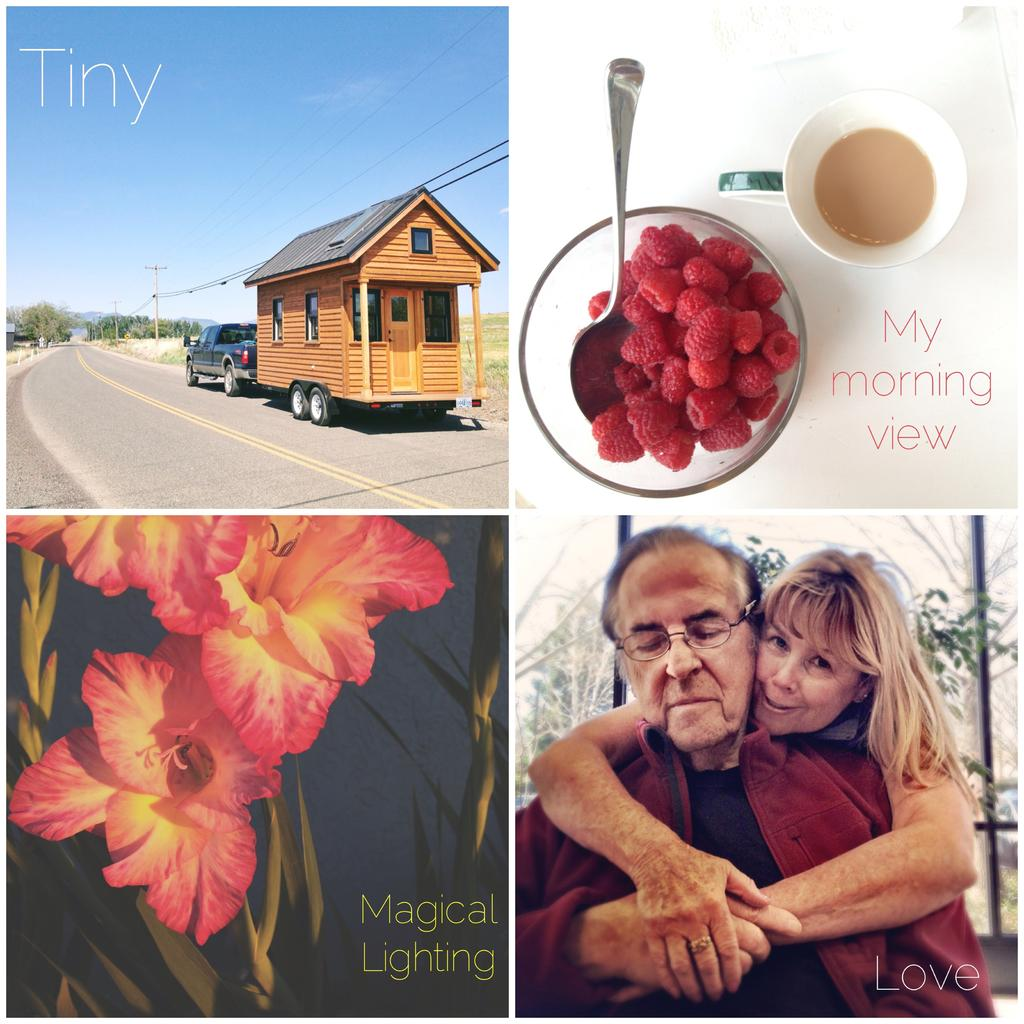How many people are in the image? There are two people in the image. What type of plants can be seen in the image? There are flowers and trees in the image. What type of structures are present in the image? There are poles and a shed in the image. What is on the road in the image? There is a vehicle on the road in the image. What type of dishware is present in the image? There is a bowl, a spoon, and a cup in the image. What else can be seen in the image? There are strawberries and some text in the image. What part of the natural environment is visible in the image? The sky is visible in the image. Can you tell me how the boat is used in the image? There is no boat present in the image. What type of crack is visible on the cup in the image? There is no crack visible on the cup in the image. 